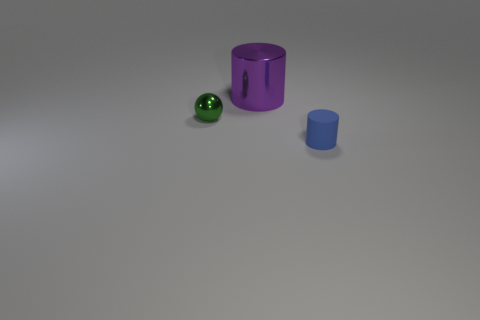How many cubes are either small matte things or green things?
Give a very brief answer. 0. The purple cylinder that is made of the same material as the ball is what size?
Your answer should be very brief. Large. Does the metal thing in front of the big purple metallic object have the same size as the object that is right of the purple cylinder?
Ensure brevity in your answer.  Yes. How many objects are big purple shiny things or yellow rubber blocks?
Make the answer very short. 1. The small green object has what shape?
Provide a succinct answer. Sphere. The blue rubber object that is the same shape as the big purple thing is what size?
Ensure brevity in your answer.  Small. Is there anything else that is made of the same material as the tiny cylinder?
Offer a terse response. No. There is a metallic object that is to the left of the cylinder behind the rubber object; how big is it?
Your answer should be very brief. Small. Is the number of rubber things that are left of the purple cylinder the same as the number of small blue cylinders?
Give a very brief answer. No. What number of other objects are there of the same color as the big metallic thing?
Provide a succinct answer. 0. 